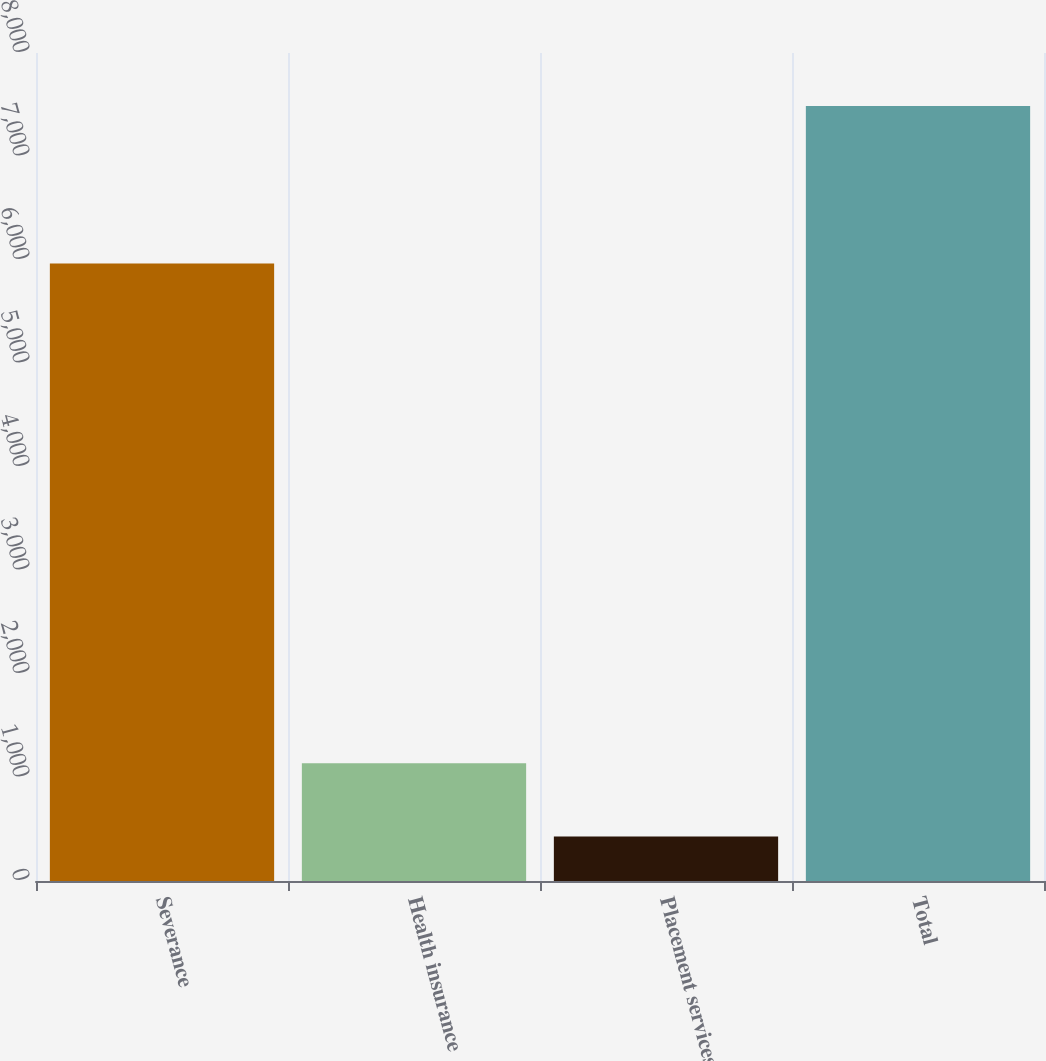Convert chart to OTSL. <chart><loc_0><loc_0><loc_500><loc_500><bar_chart><fcel>Severance<fcel>Health insurance<fcel>Placement services<fcel>Total<nl><fcel>5966<fcel>1136.8<fcel>431<fcel>7489<nl></chart> 